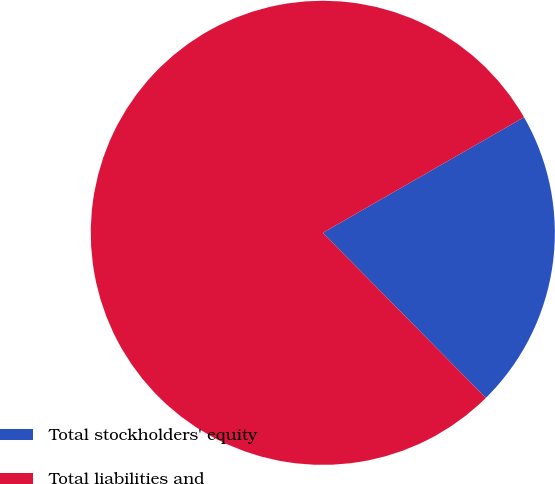Convert chart. <chart><loc_0><loc_0><loc_500><loc_500><pie_chart><fcel>Total stockholders' equity<fcel>Total liabilities and<nl><fcel>20.9%<fcel>79.1%<nl></chart> 